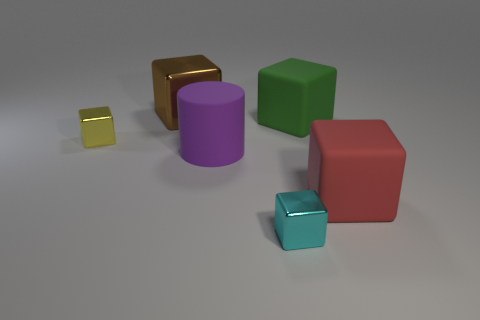What number of objects are either shiny objects in front of the red matte thing or tiny red spheres?
Keep it short and to the point. 1. The small thing that is right of the metal cube that is behind the small shiny object on the left side of the large rubber cylinder is made of what material?
Offer a very short reply. Metal. Are there more big green rubber objects behind the tiny yellow metallic block than big brown shiny blocks that are behind the big metal thing?
Keep it short and to the point. Yes. What number of blocks are either purple rubber objects or cyan things?
Give a very brief answer. 1. There is a small shiny cube in front of the rubber cube in front of the yellow cube; what number of red rubber things are left of it?
Give a very brief answer. 0. Is the number of red rubber things greater than the number of matte objects?
Your answer should be compact. No. Is the size of the green rubber object the same as the brown block?
Make the answer very short. Yes. How many things are either small yellow metal things or large blue shiny cylinders?
Offer a terse response. 1. What shape is the big rubber thing that is left of the big matte object behind the small thing that is left of the large matte cylinder?
Your answer should be very brief. Cylinder. Is the material of the tiny object that is left of the big purple matte thing the same as the big block that is to the left of the cyan object?
Your answer should be very brief. Yes. 